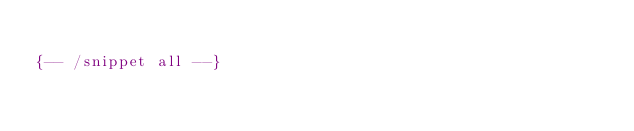<code> <loc_0><loc_0><loc_500><loc_500><_Haskell_>
{-- /snippet all --}

</code> 